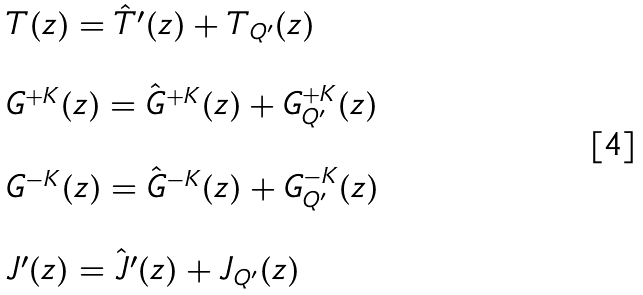<formula> <loc_0><loc_0><loc_500><loc_500>\begin{array} { l } T ( z ) = \hat { T } ^ { \prime } ( z ) + T _ { Q ^ { \prime } } ( z ) \\ \ \\ G ^ { + K } ( z ) = \hat { G } ^ { + K } ( z ) + G ^ { + K } _ { Q ^ { \prime } } ( z ) \\ \ \\ G ^ { - K } ( z ) = \hat { G } ^ { - K } ( z ) + G ^ { - K } _ { Q ^ { \prime } } ( z ) \\ \ \\ J ^ { \prime } ( z ) = \hat { J } ^ { \prime } ( z ) + J _ { Q ^ { \prime } } ( z ) \end{array}</formula> 